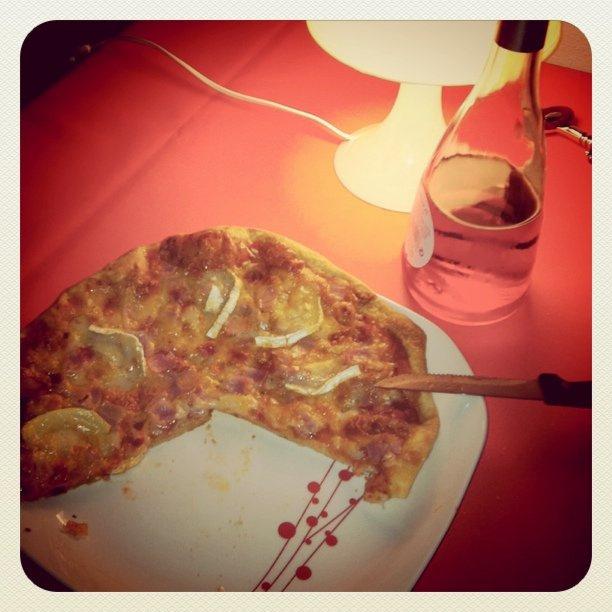What eating utensil is shown?
Short answer required. Knife. Has this food been eaten yet?
Answer briefly. Yes. What is the silver kitchen tool in the far right background called?
Be succinct. Knife. Are there any unusual toppings on this pizza?
Be succinct. Yes. 